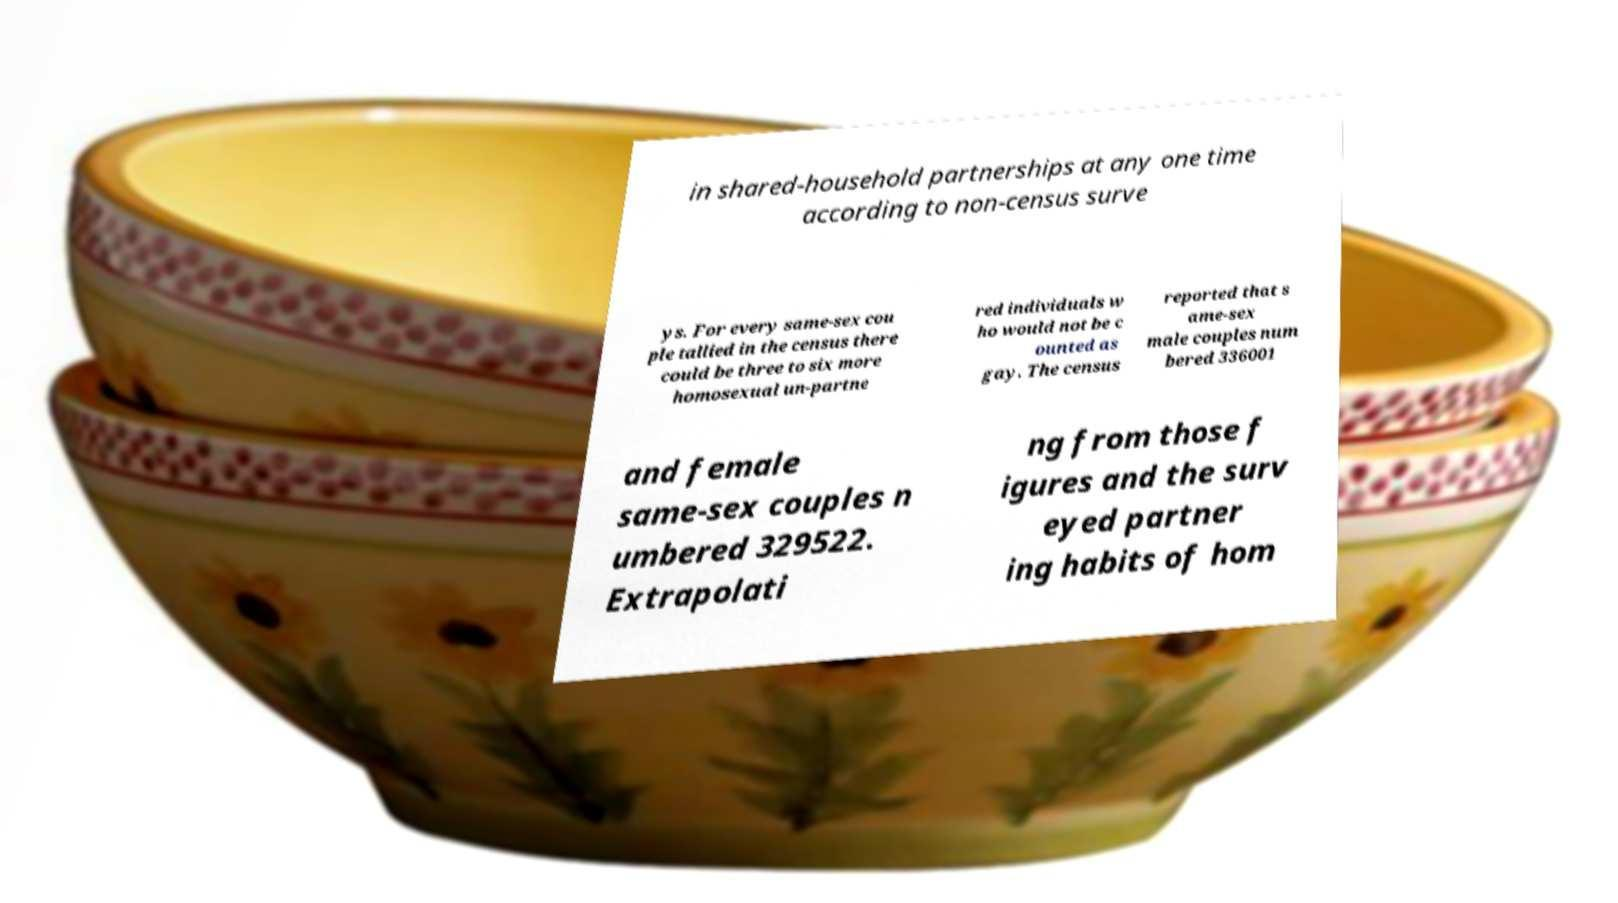There's text embedded in this image that I need extracted. Can you transcribe it verbatim? in shared-household partnerships at any one time according to non-census surve ys. For every same-sex cou ple tallied in the census there could be three to six more homosexual un-partne red individuals w ho would not be c ounted as gay. The census reported that s ame-sex male couples num bered 336001 and female same-sex couples n umbered 329522. Extrapolati ng from those f igures and the surv eyed partner ing habits of hom 